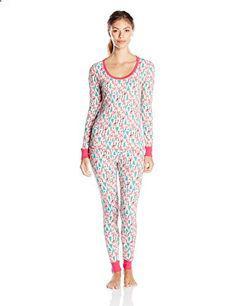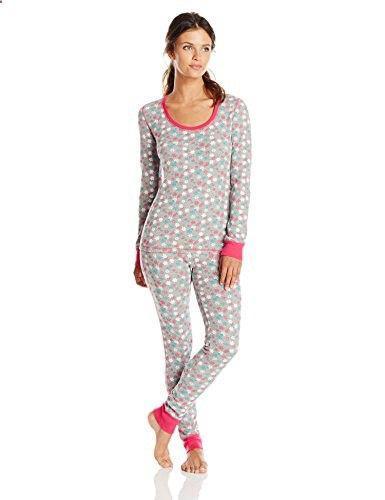The first image is the image on the left, the second image is the image on the right. Assess this claim about the two images: "There is one woman wearing tight fitting pajamas, and one woman wearing more loose fitting pajamas.". Correct or not? Answer yes or no. No. The first image is the image on the left, the second image is the image on the right. Evaluate the accuracy of this statement regarding the images: "The female in the right image is standing with her feet crossed.". Is it true? Answer yes or no. Yes. 